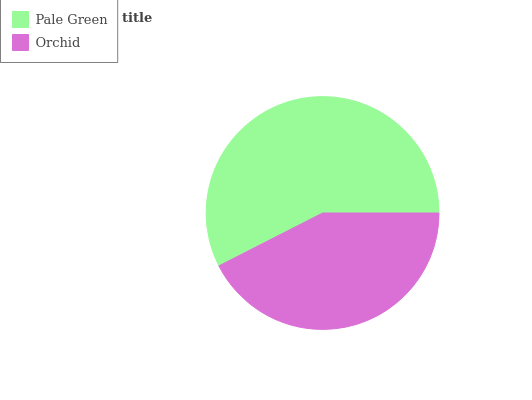Is Orchid the minimum?
Answer yes or no. Yes. Is Pale Green the maximum?
Answer yes or no. Yes. Is Orchid the maximum?
Answer yes or no. No. Is Pale Green greater than Orchid?
Answer yes or no. Yes. Is Orchid less than Pale Green?
Answer yes or no. Yes. Is Orchid greater than Pale Green?
Answer yes or no. No. Is Pale Green less than Orchid?
Answer yes or no. No. Is Pale Green the high median?
Answer yes or no. Yes. Is Orchid the low median?
Answer yes or no. Yes. Is Orchid the high median?
Answer yes or no. No. Is Pale Green the low median?
Answer yes or no. No. 